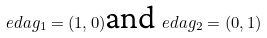<formula> <loc_0><loc_0><loc_500><loc_500>\ e d a g _ { 1 } = ( 1 , 0 ) \text {and} \ e d a g _ { 2 } = ( 0 , 1 )</formula> 